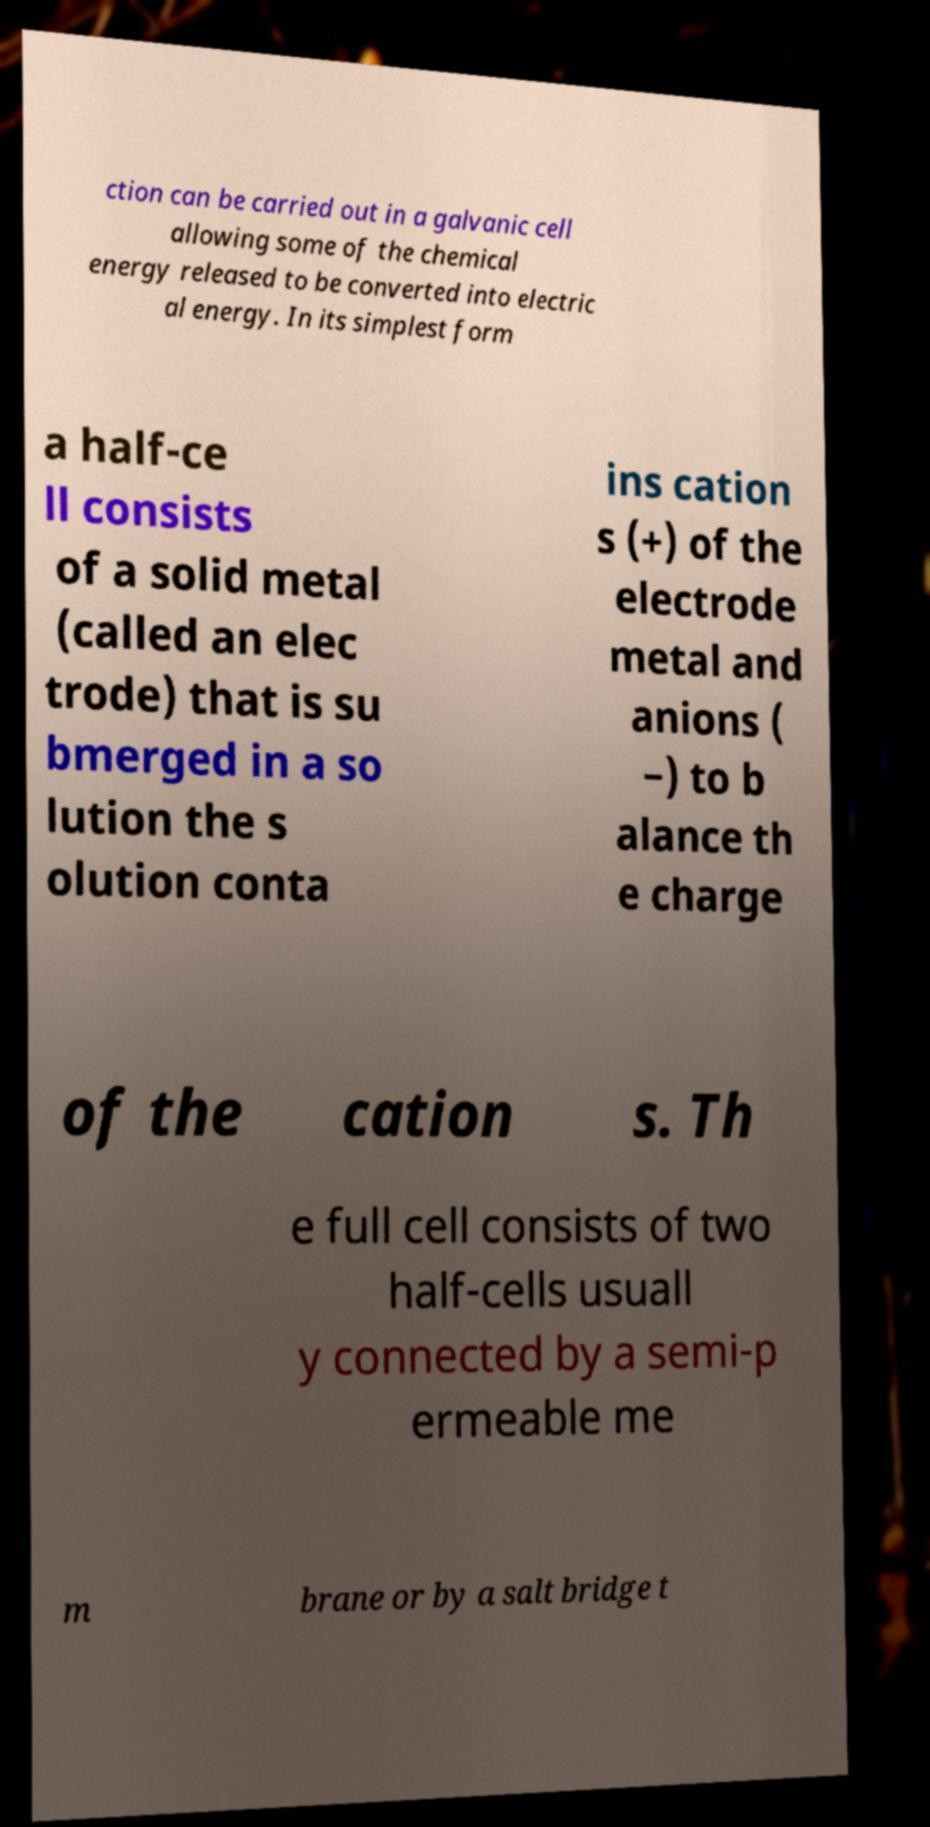Could you extract and type out the text from this image? ction can be carried out in a galvanic cell allowing some of the chemical energy released to be converted into electric al energy. In its simplest form a half-ce ll consists of a solid metal (called an elec trode) that is su bmerged in a so lution the s olution conta ins cation s (+) of the electrode metal and anions ( −) to b alance th e charge of the cation s. Th e full cell consists of two half-cells usuall y connected by a semi-p ermeable me m brane or by a salt bridge t 